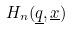<formula> <loc_0><loc_0><loc_500><loc_500>H _ { n } ( \underline { q } , \underline { x } )</formula> 